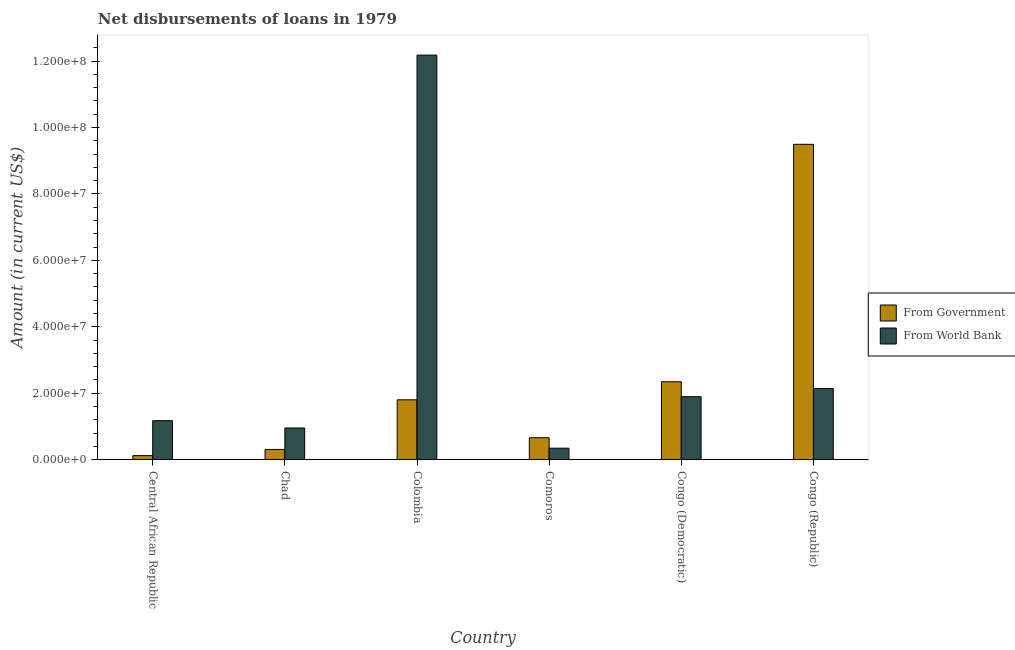How many different coloured bars are there?
Offer a terse response. 2. How many groups of bars are there?
Keep it short and to the point. 6. Are the number of bars on each tick of the X-axis equal?
Ensure brevity in your answer.  Yes. How many bars are there on the 6th tick from the left?
Keep it short and to the point. 2. What is the label of the 6th group of bars from the left?
Provide a short and direct response. Congo (Republic). What is the net disbursements of loan from government in Colombia?
Keep it short and to the point. 1.80e+07. Across all countries, what is the maximum net disbursements of loan from government?
Provide a short and direct response. 9.49e+07. Across all countries, what is the minimum net disbursements of loan from world bank?
Your response must be concise. 3.46e+06. In which country was the net disbursements of loan from government minimum?
Offer a very short reply. Central African Republic. What is the total net disbursements of loan from government in the graph?
Your answer should be compact. 1.47e+08. What is the difference between the net disbursements of loan from world bank in Central African Republic and that in Chad?
Provide a succinct answer. 2.20e+06. What is the difference between the net disbursements of loan from world bank in Chad and the net disbursements of loan from government in Congo (Democratic)?
Keep it short and to the point. -1.39e+07. What is the average net disbursements of loan from government per country?
Your answer should be very brief. 2.46e+07. What is the difference between the net disbursements of loan from government and net disbursements of loan from world bank in Congo (Democratic)?
Keep it short and to the point. 4.50e+06. What is the ratio of the net disbursements of loan from government in Chad to that in Comoros?
Your answer should be compact. 0.47. Is the net disbursements of loan from world bank in Central African Republic less than that in Congo (Democratic)?
Provide a short and direct response. Yes. What is the difference between the highest and the second highest net disbursements of loan from world bank?
Keep it short and to the point. 1.00e+08. What is the difference between the highest and the lowest net disbursements of loan from world bank?
Your answer should be compact. 1.18e+08. In how many countries, is the net disbursements of loan from world bank greater than the average net disbursements of loan from world bank taken over all countries?
Your answer should be compact. 1. What does the 2nd bar from the left in Congo (Republic) represents?
Make the answer very short. From World Bank. What does the 1st bar from the right in Congo (Democratic) represents?
Keep it short and to the point. From World Bank. Are all the bars in the graph horizontal?
Give a very brief answer. No. Does the graph contain grids?
Ensure brevity in your answer.  No. How are the legend labels stacked?
Offer a terse response. Vertical. What is the title of the graph?
Provide a succinct answer. Net disbursements of loans in 1979. What is the label or title of the X-axis?
Ensure brevity in your answer.  Country. What is the Amount (in current US$) of From Government in Central African Republic?
Give a very brief answer. 1.23e+06. What is the Amount (in current US$) of From World Bank in Central African Republic?
Provide a short and direct response. 1.17e+07. What is the Amount (in current US$) of From Government in Chad?
Make the answer very short. 3.09e+06. What is the Amount (in current US$) in From World Bank in Chad?
Offer a terse response. 9.55e+06. What is the Amount (in current US$) of From Government in Colombia?
Provide a succinct answer. 1.80e+07. What is the Amount (in current US$) of From World Bank in Colombia?
Provide a succinct answer. 1.22e+08. What is the Amount (in current US$) of From Government in Comoros?
Your response must be concise. 6.61e+06. What is the Amount (in current US$) of From World Bank in Comoros?
Make the answer very short. 3.46e+06. What is the Amount (in current US$) of From Government in Congo (Democratic)?
Provide a short and direct response. 2.35e+07. What is the Amount (in current US$) in From World Bank in Congo (Democratic)?
Give a very brief answer. 1.90e+07. What is the Amount (in current US$) in From Government in Congo (Republic)?
Keep it short and to the point. 9.49e+07. What is the Amount (in current US$) of From World Bank in Congo (Republic)?
Provide a succinct answer. 2.14e+07. Across all countries, what is the maximum Amount (in current US$) of From Government?
Provide a succinct answer. 9.49e+07. Across all countries, what is the maximum Amount (in current US$) of From World Bank?
Give a very brief answer. 1.22e+08. Across all countries, what is the minimum Amount (in current US$) of From Government?
Your answer should be compact. 1.23e+06. Across all countries, what is the minimum Amount (in current US$) of From World Bank?
Provide a short and direct response. 3.46e+06. What is the total Amount (in current US$) in From Government in the graph?
Offer a very short reply. 1.47e+08. What is the total Amount (in current US$) of From World Bank in the graph?
Your response must be concise. 1.87e+08. What is the difference between the Amount (in current US$) of From Government in Central African Republic and that in Chad?
Offer a terse response. -1.86e+06. What is the difference between the Amount (in current US$) in From World Bank in Central African Republic and that in Chad?
Make the answer very short. 2.20e+06. What is the difference between the Amount (in current US$) of From Government in Central African Republic and that in Colombia?
Your response must be concise. -1.68e+07. What is the difference between the Amount (in current US$) in From World Bank in Central African Republic and that in Colombia?
Offer a terse response. -1.10e+08. What is the difference between the Amount (in current US$) in From Government in Central African Republic and that in Comoros?
Provide a short and direct response. -5.39e+06. What is the difference between the Amount (in current US$) of From World Bank in Central African Republic and that in Comoros?
Give a very brief answer. 8.28e+06. What is the difference between the Amount (in current US$) in From Government in Central African Republic and that in Congo (Democratic)?
Give a very brief answer. -2.22e+07. What is the difference between the Amount (in current US$) in From World Bank in Central African Republic and that in Congo (Democratic)?
Your response must be concise. -7.22e+06. What is the difference between the Amount (in current US$) of From Government in Central African Republic and that in Congo (Republic)?
Provide a succinct answer. -9.37e+07. What is the difference between the Amount (in current US$) of From World Bank in Central African Republic and that in Congo (Republic)?
Offer a very short reply. -9.69e+06. What is the difference between the Amount (in current US$) in From Government in Chad and that in Colombia?
Offer a terse response. -1.49e+07. What is the difference between the Amount (in current US$) in From World Bank in Chad and that in Colombia?
Provide a short and direct response. -1.12e+08. What is the difference between the Amount (in current US$) in From Government in Chad and that in Comoros?
Your answer should be compact. -3.52e+06. What is the difference between the Amount (in current US$) in From World Bank in Chad and that in Comoros?
Your answer should be very brief. 6.08e+06. What is the difference between the Amount (in current US$) in From Government in Chad and that in Congo (Democratic)?
Provide a short and direct response. -2.04e+07. What is the difference between the Amount (in current US$) of From World Bank in Chad and that in Congo (Democratic)?
Your answer should be very brief. -9.41e+06. What is the difference between the Amount (in current US$) of From Government in Chad and that in Congo (Republic)?
Provide a short and direct response. -9.18e+07. What is the difference between the Amount (in current US$) in From World Bank in Chad and that in Congo (Republic)?
Offer a very short reply. -1.19e+07. What is the difference between the Amount (in current US$) in From Government in Colombia and that in Comoros?
Your answer should be compact. 1.14e+07. What is the difference between the Amount (in current US$) in From World Bank in Colombia and that in Comoros?
Give a very brief answer. 1.18e+08. What is the difference between the Amount (in current US$) of From Government in Colombia and that in Congo (Democratic)?
Provide a succinct answer. -5.43e+06. What is the difference between the Amount (in current US$) of From World Bank in Colombia and that in Congo (Democratic)?
Give a very brief answer. 1.03e+08. What is the difference between the Amount (in current US$) in From Government in Colombia and that in Congo (Republic)?
Provide a short and direct response. -7.69e+07. What is the difference between the Amount (in current US$) in From World Bank in Colombia and that in Congo (Republic)?
Ensure brevity in your answer.  1.00e+08. What is the difference between the Amount (in current US$) of From Government in Comoros and that in Congo (Democratic)?
Your answer should be compact. -1.68e+07. What is the difference between the Amount (in current US$) in From World Bank in Comoros and that in Congo (Democratic)?
Provide a succinct answer. -1.55e+07. What is the difference between the Amount (in current US$) in From Government in Comoros and that in Congo (Republic)?
Make the answer very short. -8.83e+07. What is the difference between the Amount (in current US$) of From World Bank in Comoros and that in Congo (Republic)?
Provide a short and direct response. -1.80e+07. What is the difference between the Amount (in current US$) in From Government in Congo (Democratic) and that in Congo (Republic)?
Keep it short and to the point. -7.15e+07. What is the difference between the Amount (in current US$) of From World Bank in Congo (Democratic) and that in Congo (Republic)?
Provide a succinct answer. -2.48e+06. What is the difference between the Amount (in current US$) in From Government in Central African Republic and the Amount (in current US$) in From World Bank in Chad?
Your response must be concise. -8.32e+06. What is the difference between the Amount (in current US$) in From Government in Central African Republic and the Amount (in current US$) in From World Bank in Colombia?
Your answer should be very brief. -1.21e+08. What is the difference between the Amount (in current US$) in From Government in Central African Republic and the Amount (in current US$) in From World Bank in Comoros?
Ensure brevity in your answer.  -2.24e+06. What is the difference between the Amount (in current US$) of From Government in Central African Republic and the Amount (in current US$) of From World Bank in Congo (Democratic)?
Provide a short and direct response. -1.77e+07. What is the difference between the Amount (in current US$) of From Government in Central African Republic and the Amount (in current US$) of From World Bank in Congo (Republic)?
Provide a succinct answer. -2.02e+07. What is the difference between the Amount (in current US$) of From Government in Chad and the Amount (in current US$) of From World Bank in Colombia?
Give a very brief answer. -1.19e+08. What is the difference between the Amount (in current US$) of From Government in Chad and the Amount (in current US$) of From World Bank in Comoros?
Provide a succinct answer. -3.78e+05. What is the difference between the Amount (in current US$) of From Government in Chad and the Amount (in current US$) of From World Bank in Congo (Democratic)?
Offer a very short reply. -1.59e+07. What is the difference between the Amount (in current US$) of From Government in Chad and the Amount (in current US$) of From World Bank in Congo (Republic)?
Ensure brevity in your answer.  -1.84e+07. What is the difference between the Amount (in current US$) of From Government in Colombia and the Amount (in current US$) of From World Bank in Comoros?
Offer a terse response. 1.46e+07. What is the difference between the Amount (in current US$) in From Government in Colombia and the Amount (in current US$) in From World Bank in Congo (Democratic)?
Your response must be concise. -9.34e+05. What is the difference between the Amount (in current US$) in From Government in Colombia and the Amount (in current US$) in From World Bank in Congo (Republic)?
Offer a very short reply. -3.41e+06. What is the difference between the Amount (in current US$) in From Government in Comoros and the Amount (in current US$) in From World Bank in Congo (Democratic)?
Ensure brevity in your answer.  -1.24e+07. What is the difference between the Amount (in current US$) in From Government in Comoros and the Amount (in current US$) in From World Bank in Congo (Republic)?
Provide a short and direct response. -1.48e+07. What is the difference between the Amount (in current US$) in From Government in Congo (Democratic) and the Amount (in current US$) in From World Bank in Congo (Republic)?
Keep it short and to the point. 2.02e+06. What is the average Amount (in current US$) in From Government per country?
Offer a very short reply. 2.46e+07. What is the average Amount (in current US$) in From World Bank per country?
Offer a terse response. 3.12e+07. What is the difference between the Amount (in current US$) in From Government and Amount (in current US$) in From World Bank in Central African Republic?
Give a very brief answer. -1.05e+07. What is the difference between the Amount (in current US$) of From Government and Amount (in current US$) of From World Bank in Chad?
Keep it short and to the point. -6.46e+06. What is the difference between the Amount (in current US$) in From Government and Amount (in current US$) in From World Bank in Colombia?
Ensure brevity in your answer.  -1.04e+08. What is the difference between the Amount (in current US$) of From Government and Amount (in current US$) of From World Bank in Comoros?
Keep it short and to the point. 3.15e+06. What is the difference between the Amount (in current US$) of From Government and Amount (in current US$) of From World Bank in Congo (Democratic)?
Your answer should be compact. 4.50e+06. What is the difference between the Amount (in current US$) in From Government and Amount (in current US$) in From World Bank in Congo (Republic)?
Your response must be concise. 7.35e+07. What is the ratio of the Amount (in current US$) in From Government in Central African Republic to that in Chad?
Your answer should be compact. 0.4. What is the ratio of the Amount (in current US$) in From World Bank in Central African Republic to that in Chad?
Your response must be concise. 1.23. What is the ratio of the Amount (in current US$) in From Government in Central African Republic to that in Colombia?
Keep it short and to the point. 0.07. What is the ratio of the Amount (in current US$) of From World Bank in Central African Republic to that in Colombia?
Provide a succinct answer. 0.1. What is the ratio of the Amount (in current US$) in From Government in Central African Republic to that in Comoros?
Ensure brevity in your answer.  0.19. What is the ratio of the Amount (in current US$) of From World Bank in Central African Republic to that in Comoros?
Offer a very short reply. 3.39. What is the ratio of the Amount (in current US$) in From Government in Central African Republic to that in Congo (Democratic)?
Offer a terse response. 0.05. What is the ratio of the Amount (in current US$) of From World Bank in Central African Republic to that in Congo (Democratic)?
Make the answer very short. 0.62. What is the ratio of the Amount (in current US$) of From Government in Central African Republic to that in Congo (Republic)?
Your response must be concise. 0.01. What is the ratio of the Amount (in current US$) of From World Bank in Central African Republic to that in Congo (Republic)?
Provide a succinct answer. 0.55. What is the ratio of the Amount (in current US$) of From Government in Chad to that in Colombia?
Offer a very short reply. 0.17. What is the ratio of the Amount (in current US$) of From World Bank in Chad to that in Colombia?
Your answer should be very brief. 0.08. What is the ratio of the Amount (in current US$) of From Government in Chad to that in Comoros?
Your answer should be compact. 0.47. What is the ratio of the Amount (in current US$) in From World Bank in Chad to that in Comoros?
Ensure brevity in your answer.  2.76. What is the ratio of the Amount (in current US$) of From Government in Chad to that in Congo (Democratic)?
Your answer should be compact. 0.13. What is the ratio of the Amount (in current US$) of From World Bank in Chad to that in Congo (Democratic)?
Make the answer very short. 0.5. What is the ratio of the Amount (in current US$) of From Government in Chad to that in Congo (Republic)?
Offer a terse response. 0.03. What is the ratio of the Amount (in current US$) of From World Bank in Chad to that in Congo (Republic)?
Keep it short and to the point. 0.45. What is the ratio of the Amount (in current US$) of From Government in Colombia to that in Comoros?
Your answer should be compact. 2.73. What is the ratio of the Amount (in current US$) in From World Bank in Colombia to that in Comoros?
Your response must be concise. 35.15. What is the ratio of the Amount (in current US$) in From Government in Colombia to that in Congo (Democratic)?
Your response must be concise. 0.77. What is the ratio of the Amount (in current US$) of From World Bank in Colombia to that in Congo (Democratic)?
Ensure brevity in your answer.  6.42. What is the ratio of the Amount (in current US$) in From Government in Colombia to that in Congo (Republic)?
Offer a terse response. 0.19. What is the ratio of the Amount (in current US$) in From World Bank in Colombia to that in Congo (Republic)?
Provide a succinct answer. 5.68. What is the ratio of the Amount (in current US$) in From Government in Comoros to that in Congo (Democratic)?
Ensure brevity in your answer.  0.28. What is the ratio of the Amount (in current US$) of From World Bank in Comoros to that in Congo (Democratic)?
Ensure brevity in your answer.  0.18. What is the ratio of the Amount (in current US$) in From Government in Comoros to that in Congo (Republic)?
Provide a short and direct response. 0.07. What is the ratio of the Amount (in current US$) in From World Bank in Comoros to that in Congo (Republic)?
Give a very brief answer. 0.16. What is the ratio of the Amount (in current US$) of From Government in Congo (Democratic) to that in Congo (Republic)?
Keep it short and to the point. 0.25. What is the ratio of the Amount (in current US$) in From World Bank in Congo (Democratic) to that in Congo (Republic)?
Give a very brief answer. 0.88. What is the difference between the highest and the second highest Amount (in current US$) in From Government?
Ensure brevity in your answer.  7.15e+07. What is the difference between the highest and the second highest Amount (in current US$) of From World Bank?
Give a very brief answer. 1.00e+08. What is the difference between the highest and the lowest Amount (in current US$) in From Government?
Your response must be concise. 9.37e+07. What is the difference between the highest and the lowest Amount (in current US$) in From World Bank?
Offer a very short reply. 1.18e+08. 